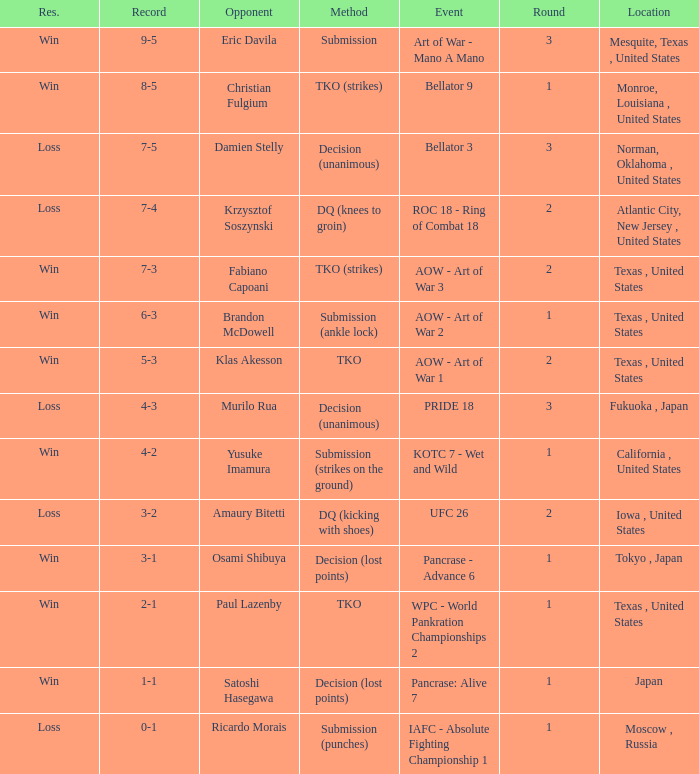What is the average round against opponent Klas Akesson? 2.0. 